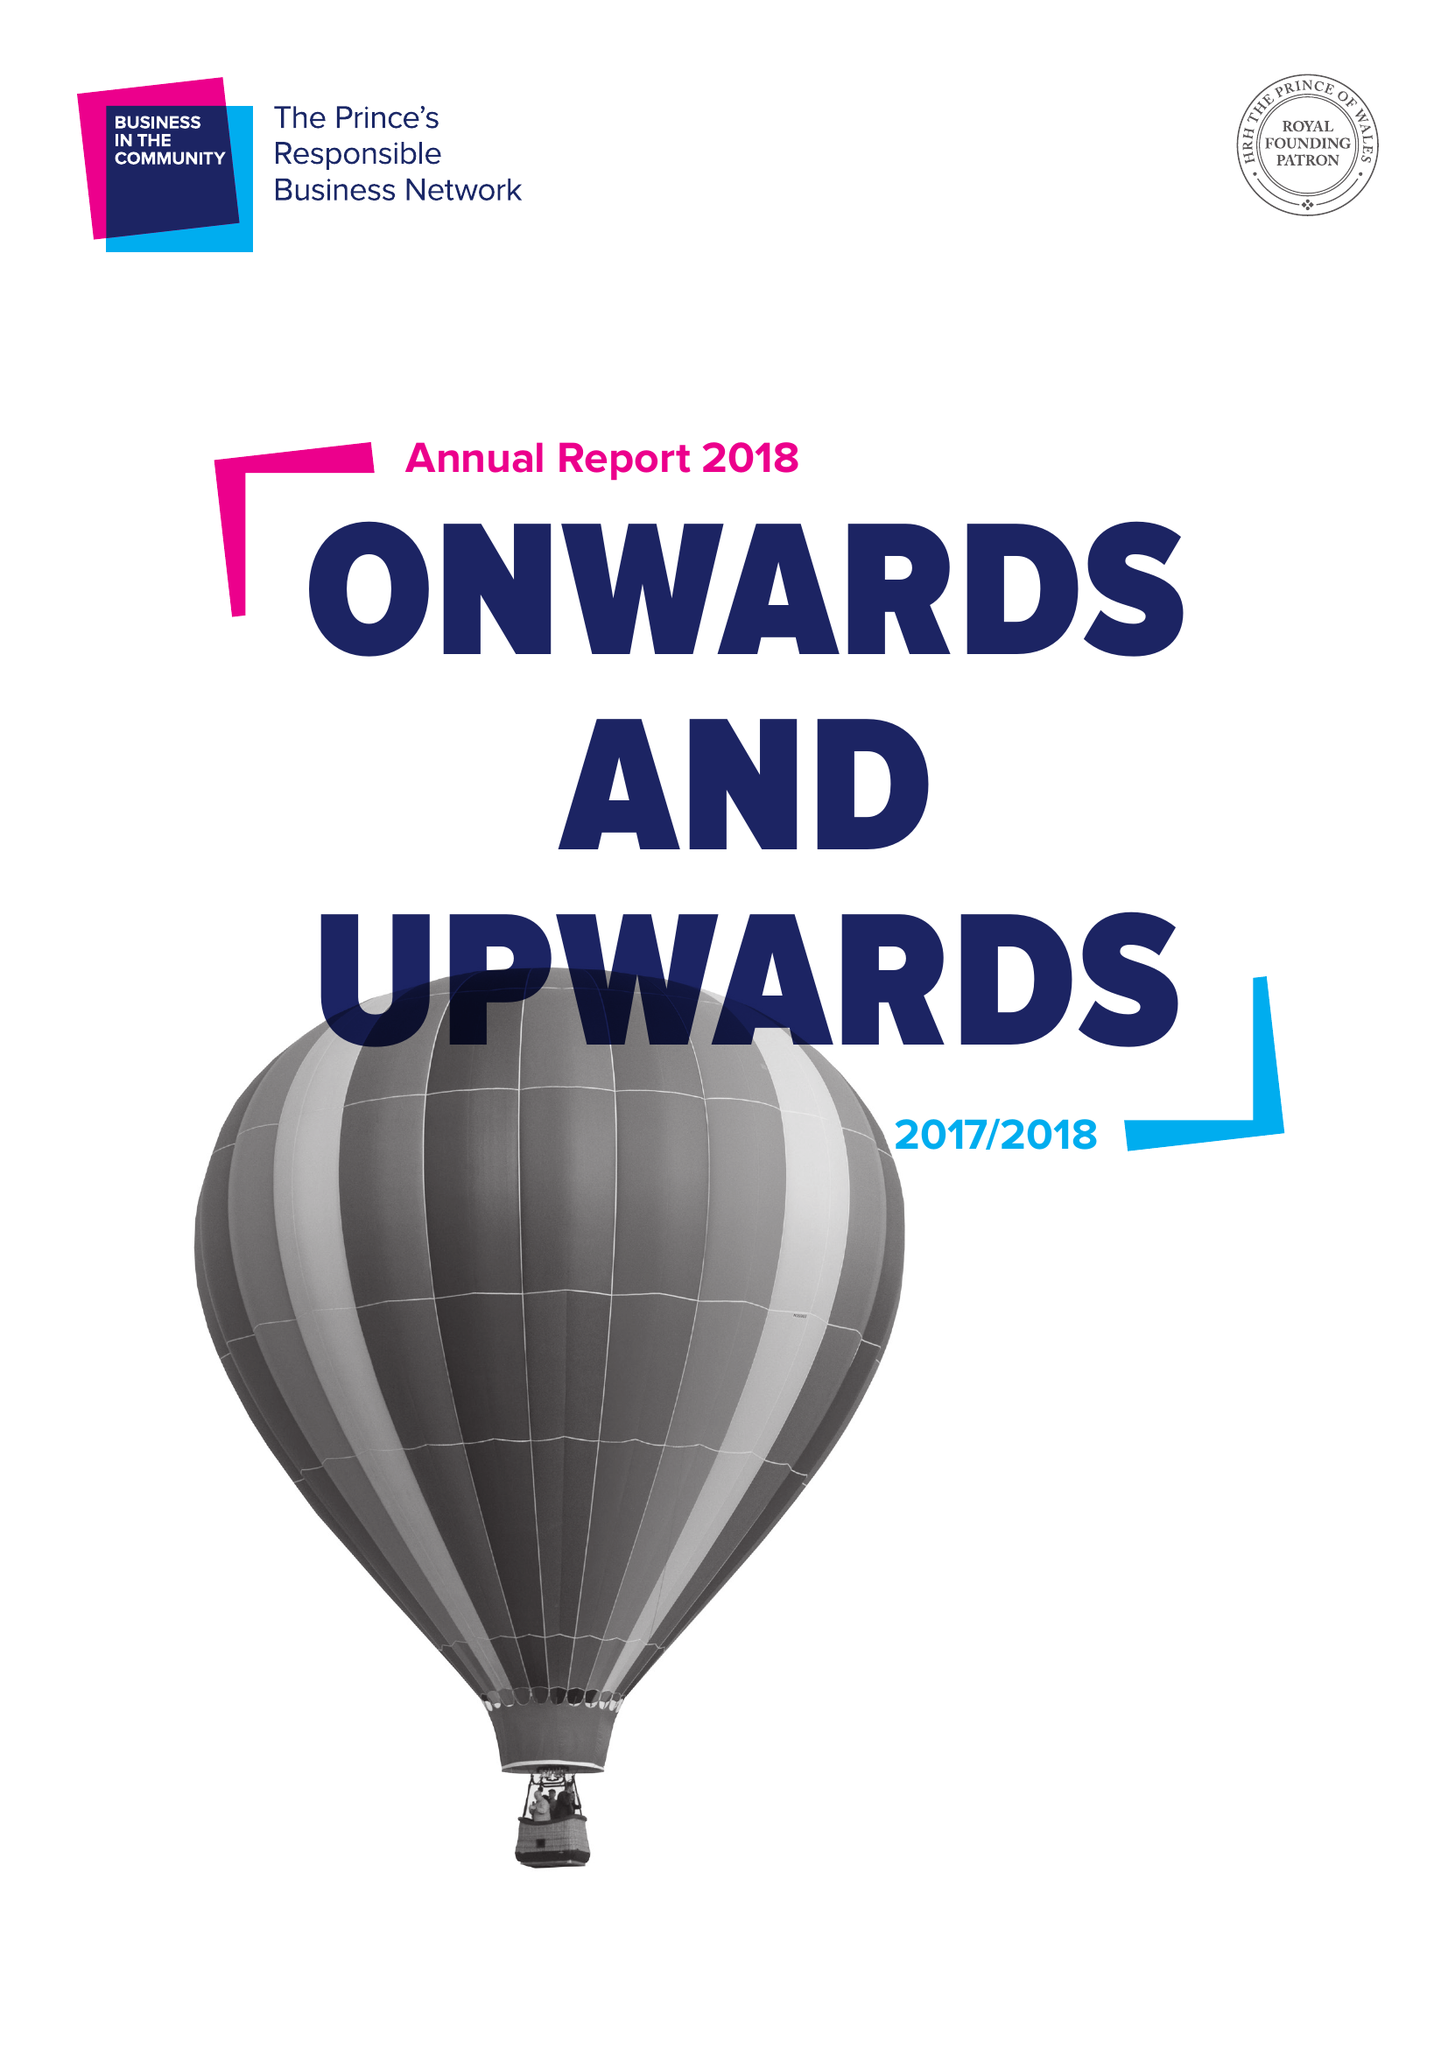What is the value for the address__post_town?
Answer the question using a single word or phrase. LONDON 